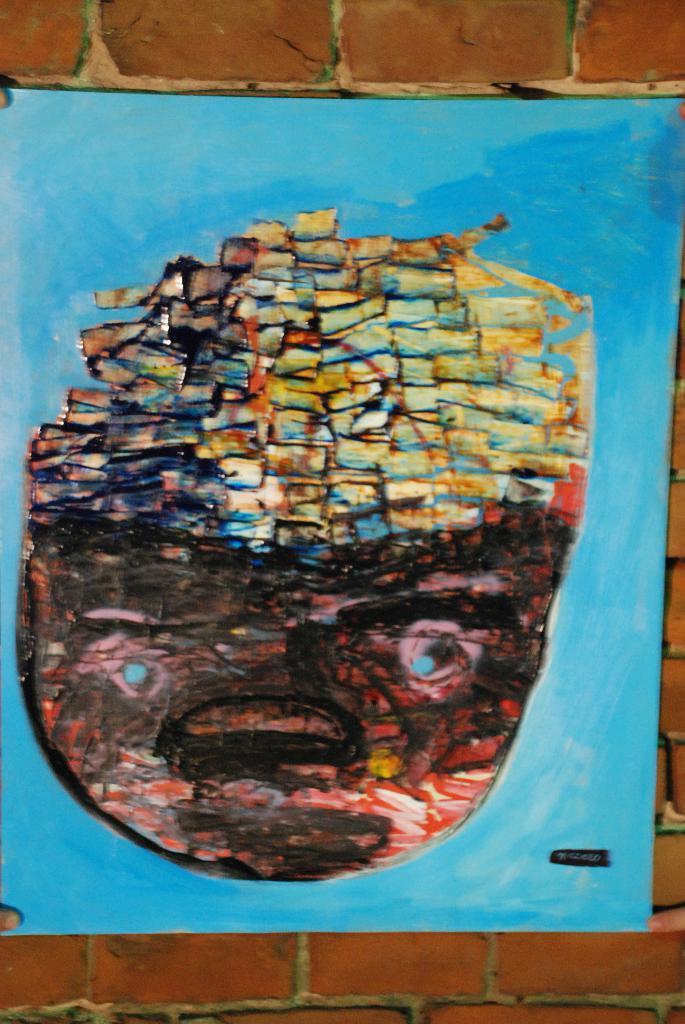Can you describe this image briefly? In this picture there is a painted chart in the center of the image, which is placed on the wall. 